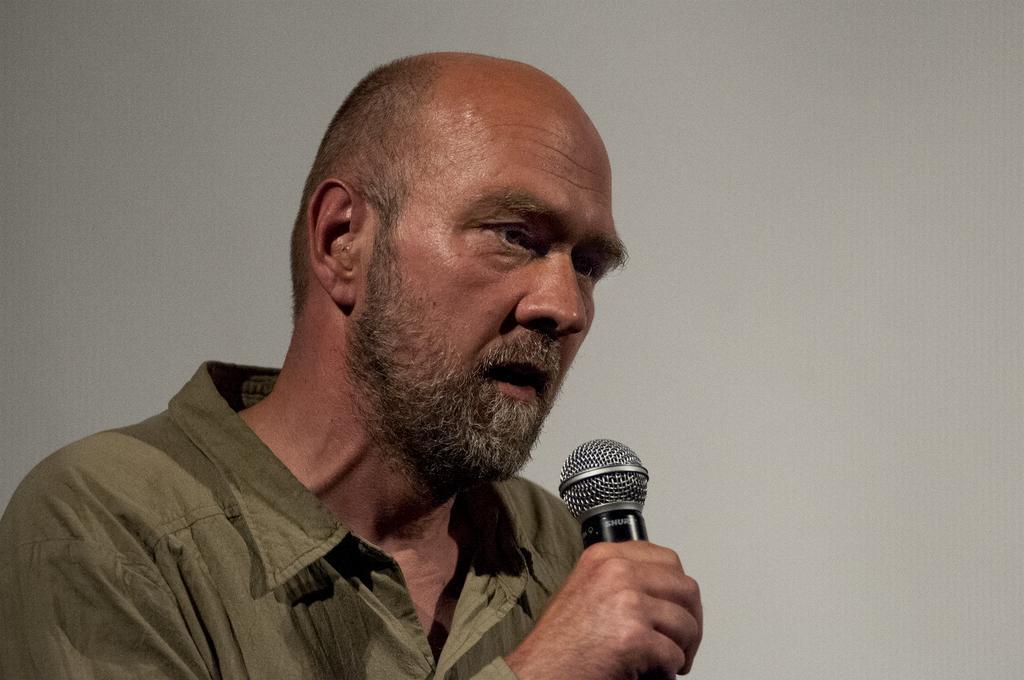Please provide a concise description of this image. In this picture we can see a man, he is speaking with the help of microphone. 